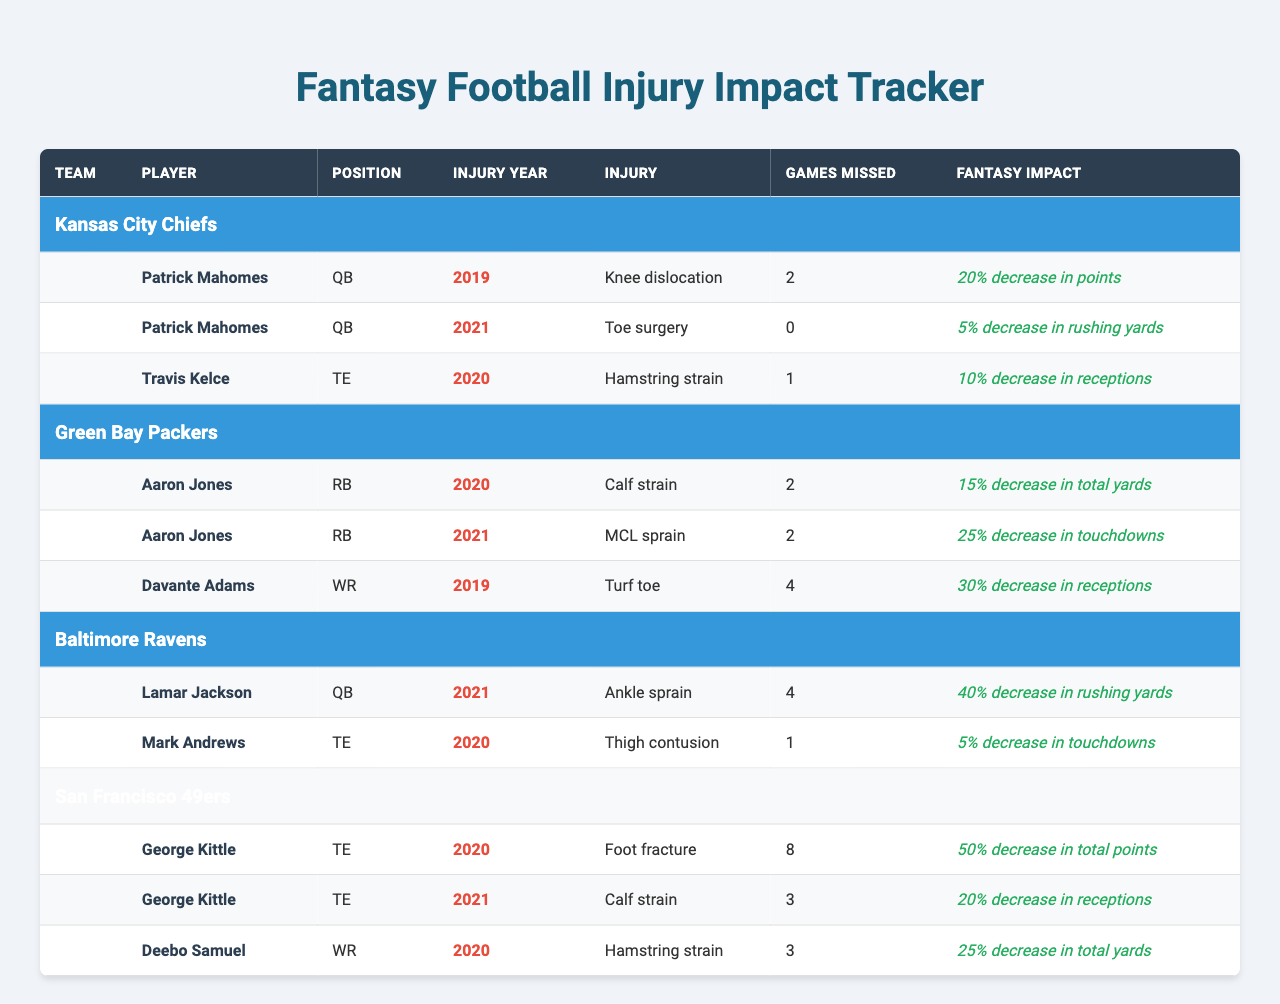What player from the Green Bay Packers had a calf strain injury? The table indicates that Aaron Jones from the Green Bay Packers had a calf strain injury in 2020.
Answer: Aaron Jones How many total games did George Kittle miss due to injuries in 2020? George Kittle missed 8 games due to a foot fracture and 3 games due to a calf strain in 2021. However, we need to consider only the injuries from 2020, where he missed 8 games.
Answer: 8 Which player had the highest fantasy impact decrease and what was the percentage? By checking the fantasy impacts listed, George Kittle had a 50% decrease in total points in 2020, which is the highest among all players.
Answer: 50% Did Travis Kelce miss any games in 2021? According to the table, Travis Kelce did not miss any games in 2021 due to his toe surgery.
Answer: No How many touchdowns did Aaron Jones’ injuries affect over the years? Aaron Jones missed 2 games in 2020 due to a calf strain which led to a 15% decrease in total yards, and in 2021, he missed 2 more games due to an MCL sprain causing a 25% decrease in touchdowns. We need to focus on the second injury for touchdowns, therefore he was affected in total by a 25% decrease.
Answer: 25% Compare the average games missed by players in the Kansas City Chiefs to those in the Green Bay Packers. For the Kansas City Chiefs, Patrick Mahomes missed 2 games in 2019 and 0 in 2021, giving an average of (2 + 0)/2 = 1. For the Green Bay Packers, Aaron Jones missed 2 games in 2020 and 2 in 2021, averaging (2 + 2)/2 = 2. This shows a difference, and Packers players missed more games on average.
Answer: Chiefs: 1, Packers: 2 Which injured player missed the most games and how many? From the table, George Kittle missed the most games, totaling 8 games due to a foot fracture in 2020.
Answer: George Kittle, 8 games Did any player miss games due to an ankle sprain? The table shows that Lamar Jackson missed 4 games in 2021 due to an ankle sprain. This confirms that a player indeed missed games due to this injury.
Answer: Yes What is the total percentage of fantasy impact decrease for Aaron Jones across both injuries? Aaron Jones had a 15% decrease in total yards from his calf strain in 2020 and a 25% decrease in touchdowns due to an MCL sprain in 2021. Adding these percentages gives a total of 15 + 25 = 40%.
Answer: 40% 